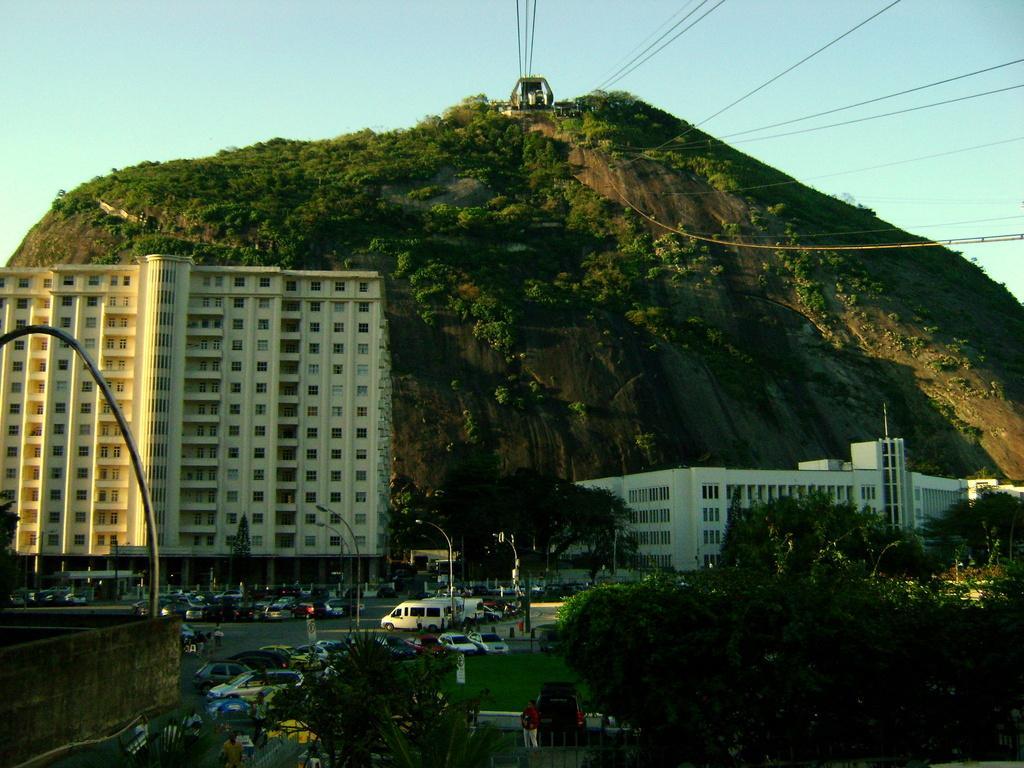Can you describe this image briefly? In the foreground of this picture, there are trees, poles, vehicles on the road, a cliff, and an electric cable car. 